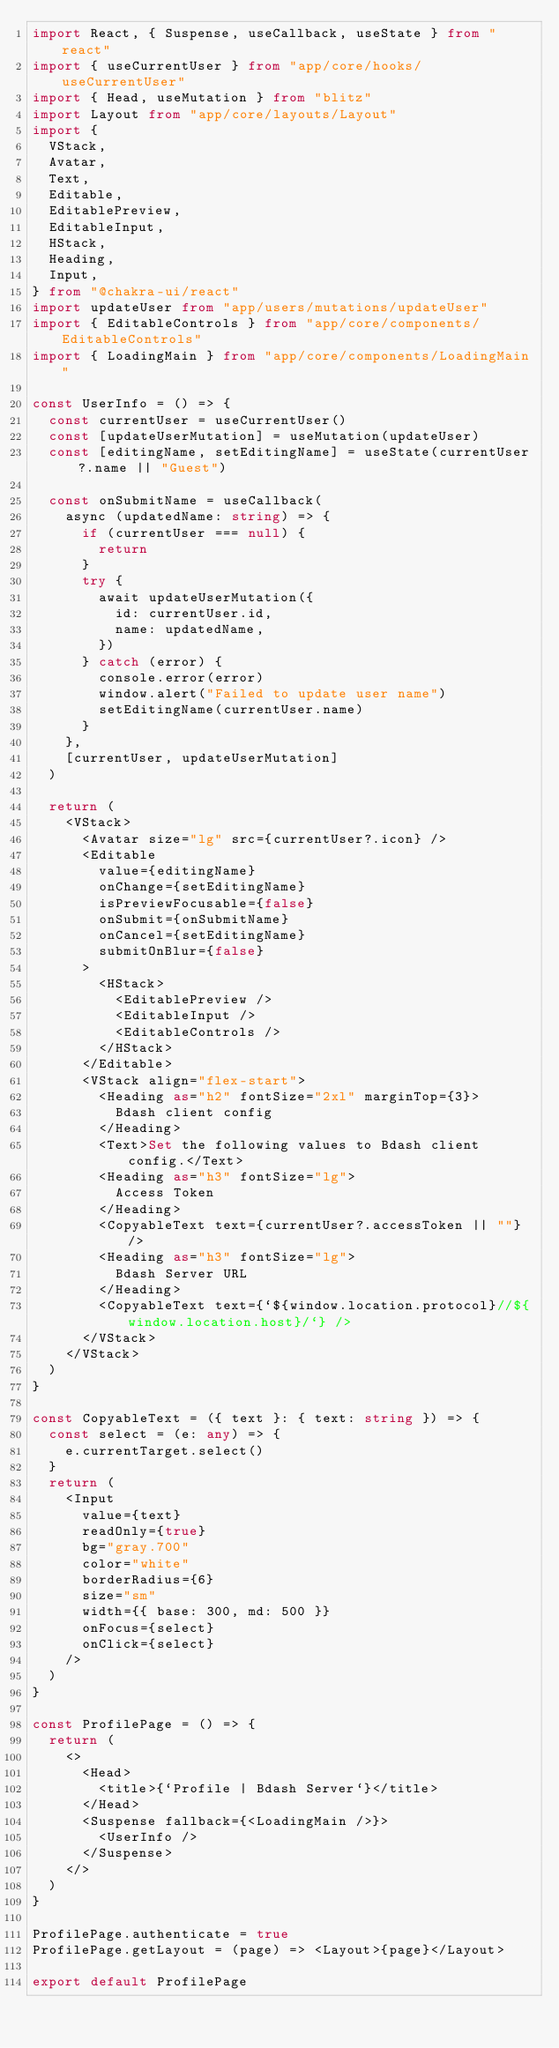Convert code to text. <code><loc_0><loc_0><loc_500><loc_500><_TypeScript_>import React, { Suspense, useCallback, useState } from "react"
import { useCurrentUser } from "app/core/hooks/useCurrentUser"
import { Head, useMutation } from "blitz"
import Layout from "app/core/layouts/Layout"
import {
  VStack,
  Avatar,
  Text,
  Editable,
  EditablePreview,
  EditableInput,
  HStack,
  Heading,
  Input,
} from "@chakra-ui/react"
import updateUser from "app/users/mutations/updateUser"
import { EditableControls } from "app/core/components/EditableControls"
import { LoadingMain } from "app/core/components/LoadingMain"

const UserInfo = () => {
  const currentUser = useCurrentUser()
  const [updateUserMutation] = useMutation(updateUser)
  const [editingName, setEditingName] = useState(currentUser?.name || "Guest")

  const onSubmitName = useCallback(
    async (updatedName: string) => {
      if (currentUser === null) {
        return
      }
      try {
        await updateUserMutation({
          id: currentUser.id,
          name: updatedName,
        })
      } catch (error) {
        console.error(error)
        window.alert("Failed to update user name")
        setEditingName(currentUser.name)
      }
    },
    [currentUser, updateUserMutation]
  )

  return (
    <VStack>
      <Avatar size="lg" src={currentUser?.icon} />
      <Editable
        value={editingName}
        onChange={setEditingName}
        isPreviewFocusable={false}
        onSubmit={onSubmitName}
        onCancel={setEditingName}
        submitOnBlur={false}
      >
        <HStack>
          <EditablePreview />
          <EditableInput />
          <EditableControls />
        </HStack>
      </Editable>
      <VStack align="flex-start">
        <Heading as="h2" fontSize="2xl" marginTop={3}>
          Bdash client config
        </Heading>
        <Text>Set the following values to Bdash client config.</Text>
        <Heading as="h3" fontSize="lg">
          Access Token
        </Heading>
        <CopyableText text={currentUser?.accessToken || ""} />
        <Heading as="h3" fontSize="lg">
          Bdash Server URL
        </Heading>
        <CopyableText text={`${window.location.protocol}//${window.location.host}/`} />
      </VStack>
    </VStack>
  )
}

const CopyableText = ({ text }: { text: string }) => {
  const select = (e: any) => {
    e.currentTarget.select()
  }
  return (
    <Input
      value={text}
      readOnly={true}
      bg="gray.700"
      color="white"
      borderRadius={6}
      size="sm"
      width={{ base: 300, md: 500 }}
      onFocus={select}
      onClick={select}
    />
  )
}

const ProfilePage = () => {
  return (
    <>
      <Head>
        <title>{`Profile | Bdash Server`}</title>
      </Head>
      <Suspense fallback={<LoadingMain />}>
        <UserInfo />
      </Suspense>
    </>
  )
}

ProfilePage.authenticate = true
ProfilePage.getLayout = (page) => <Layout>{page}</Layout>

export default ProfilePage
</code> 